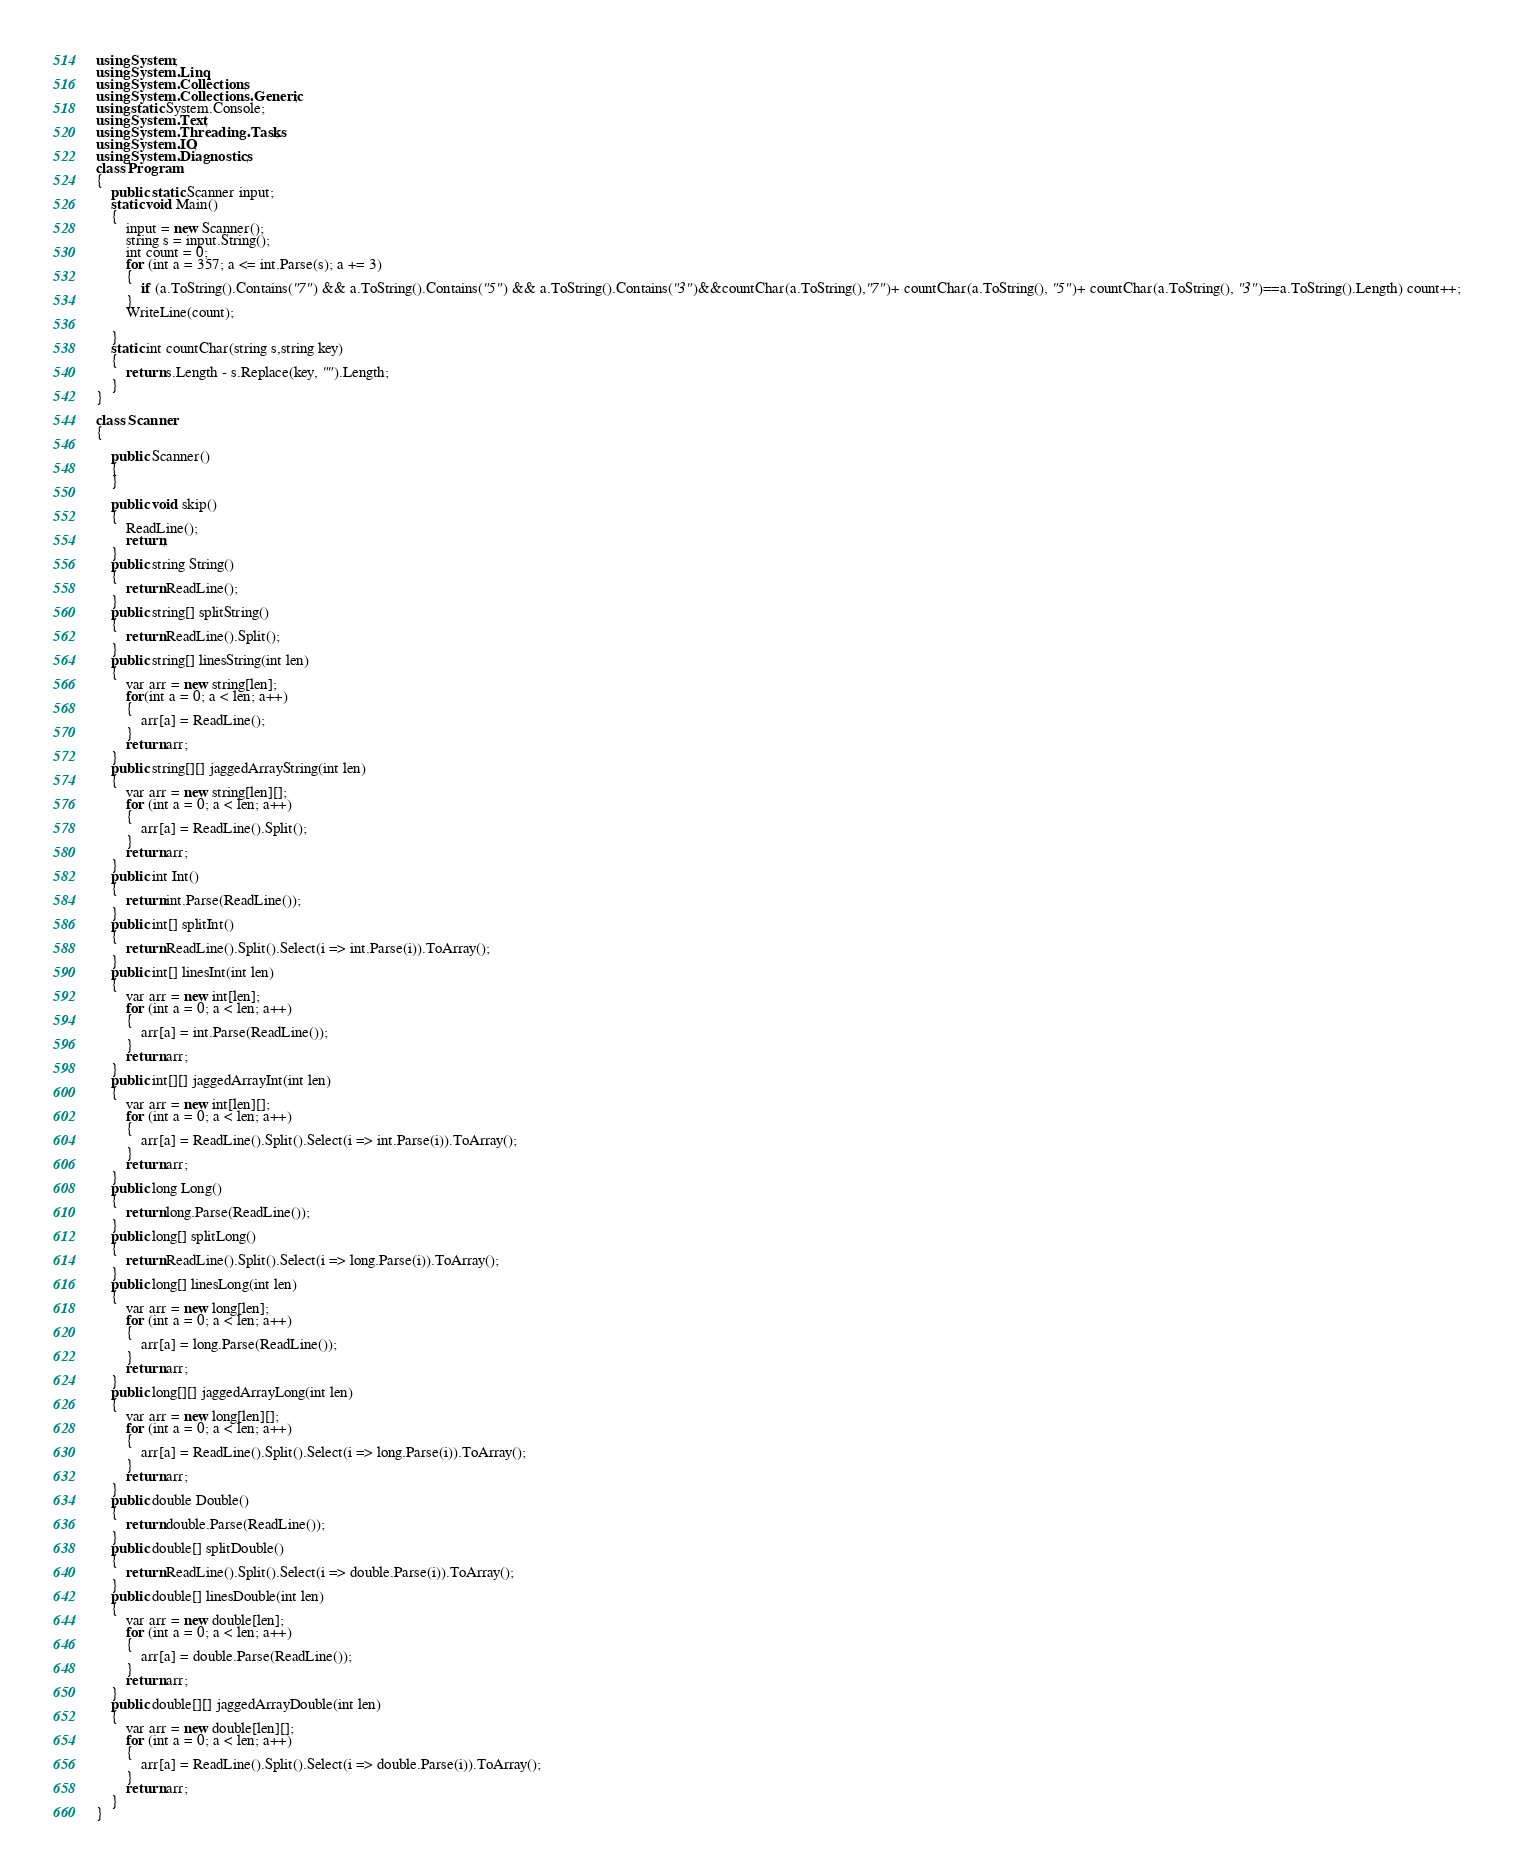<code> <loc_0><loc_0><loc_500><loc_500><_C#_>using System;
using System.Linq;
using System.Collections;
using System.Collections.Generic;
using static System.Console;
using System.Text;
using System.Threading.Tasks;
using System.IO;
using System.Diagnostics;
class Program
{
    public static Scanner input;
    static void Main()
    {
        input = new Scanner();
        string s = input.String();
        int count = 0;
        for (int a = 357; a <= int.Parse(s); a += 3)
        {
            if (a.ToString().Contains("7") && a.ToString().Contains("5") && a.ToString().Contains("3")&&countChar(a.ToString(),"7")+ countChar(a.ToString(), "5")+ countChar(a.ToString(), "3")==a.ToString().Length) count++;
        }
        WriteLine(count);

    }
    static int countChar(string s,string key)
    {
        return s.Length - s.Replace(key, "").Length;
    }
}

class Scanner
{

    public Scanner()
    {
    }

    public void skip()
    {
        ReadLine();
        return;
    }
    public string String()
    {
        return ReadLine();
    }
    public string[] splitString()
    {
        return ReadLine().Split();
    }
    public string[] linesString(int len)
    {
        var arr = new string[len];
        for(int a = 0; a < len; a++)
        {
            arr[a] = ReadLine();
        }
        return arr;
    }
    public string[][] jaggedArrayString(int len)
    {
        var arr = new string[len][];
        for (int a = 0; a < len; a++)
        {
            arr[a] = ReadLine().Split();
        }
        return arr;
    }
    public int Int()
    {
        return int.Parse(ReadLine());
    }
    public int[] splitInt()
    {
        return ReadLine().Split().Select(i => int.Parse(i)).ToArray();
    }
    public int[] linesInt(int len)
    {
        var arr = new int[len];
        for (int a = 0; a < len; a++)
        {
            arr[a] = int.Parse(ReadLine());
        }
        return arr;
    }
    public int[][] jaggedArrayInt(int len)
    {
        var arr = new int[len][];
        for (int a = 0; a < len; a++)
        {
            arr[a] = ReadLine().Split().Select(i => int.Parse(i)).ToArray();
        }
        return arr;
    }
    public long Long()
    {
        return long.Parse(ReadLine());
    }
    public long[] splitLong()
    {
        return ReadLine().Split().Select(i => long.Parse(i)).ToArray();
    }
    public long[] linesLong(int len)
    {
        var arr = new long[len];
        for (int a = 0; a < len; a++)
        {
            arr[a] = long.Parse(ReadLine());
        }
        return arr;
    }
    public long[][] jaggedArrayLong(int len)
    {
        var arr = new long[len][];
        for (int a = 0; a < len; a++)
        {
            arr[a] = ReadLine().Split().Select(i => long.Parse(i)).ToArray();
        }
        return arr;
    }
    public double Double()
    {
        return double.Parse(ReadLine());
    }
    public double[] splitDouble()
    {
        return ReadLine().Split().Select(i => double.Parse(i)).ToArray();
    }
    public double[] linesDouble(int len)
    {
        var arr = new double[len];
        for (int a = 0; a < len; a++)
        {
            arr[a] = double.Parse(ReadLine());
        }
        return arr;
    }
    public double[][] jaggedArrayDouble(int len)
    {
        var arr = new double[len][];
        for (int a = 0; a < len; a++)
        {
            arr[a] = ReadLine().Split().Select(i => double.Parse(i)).ToArray();
        }
        return arr;
    }
}</code> 